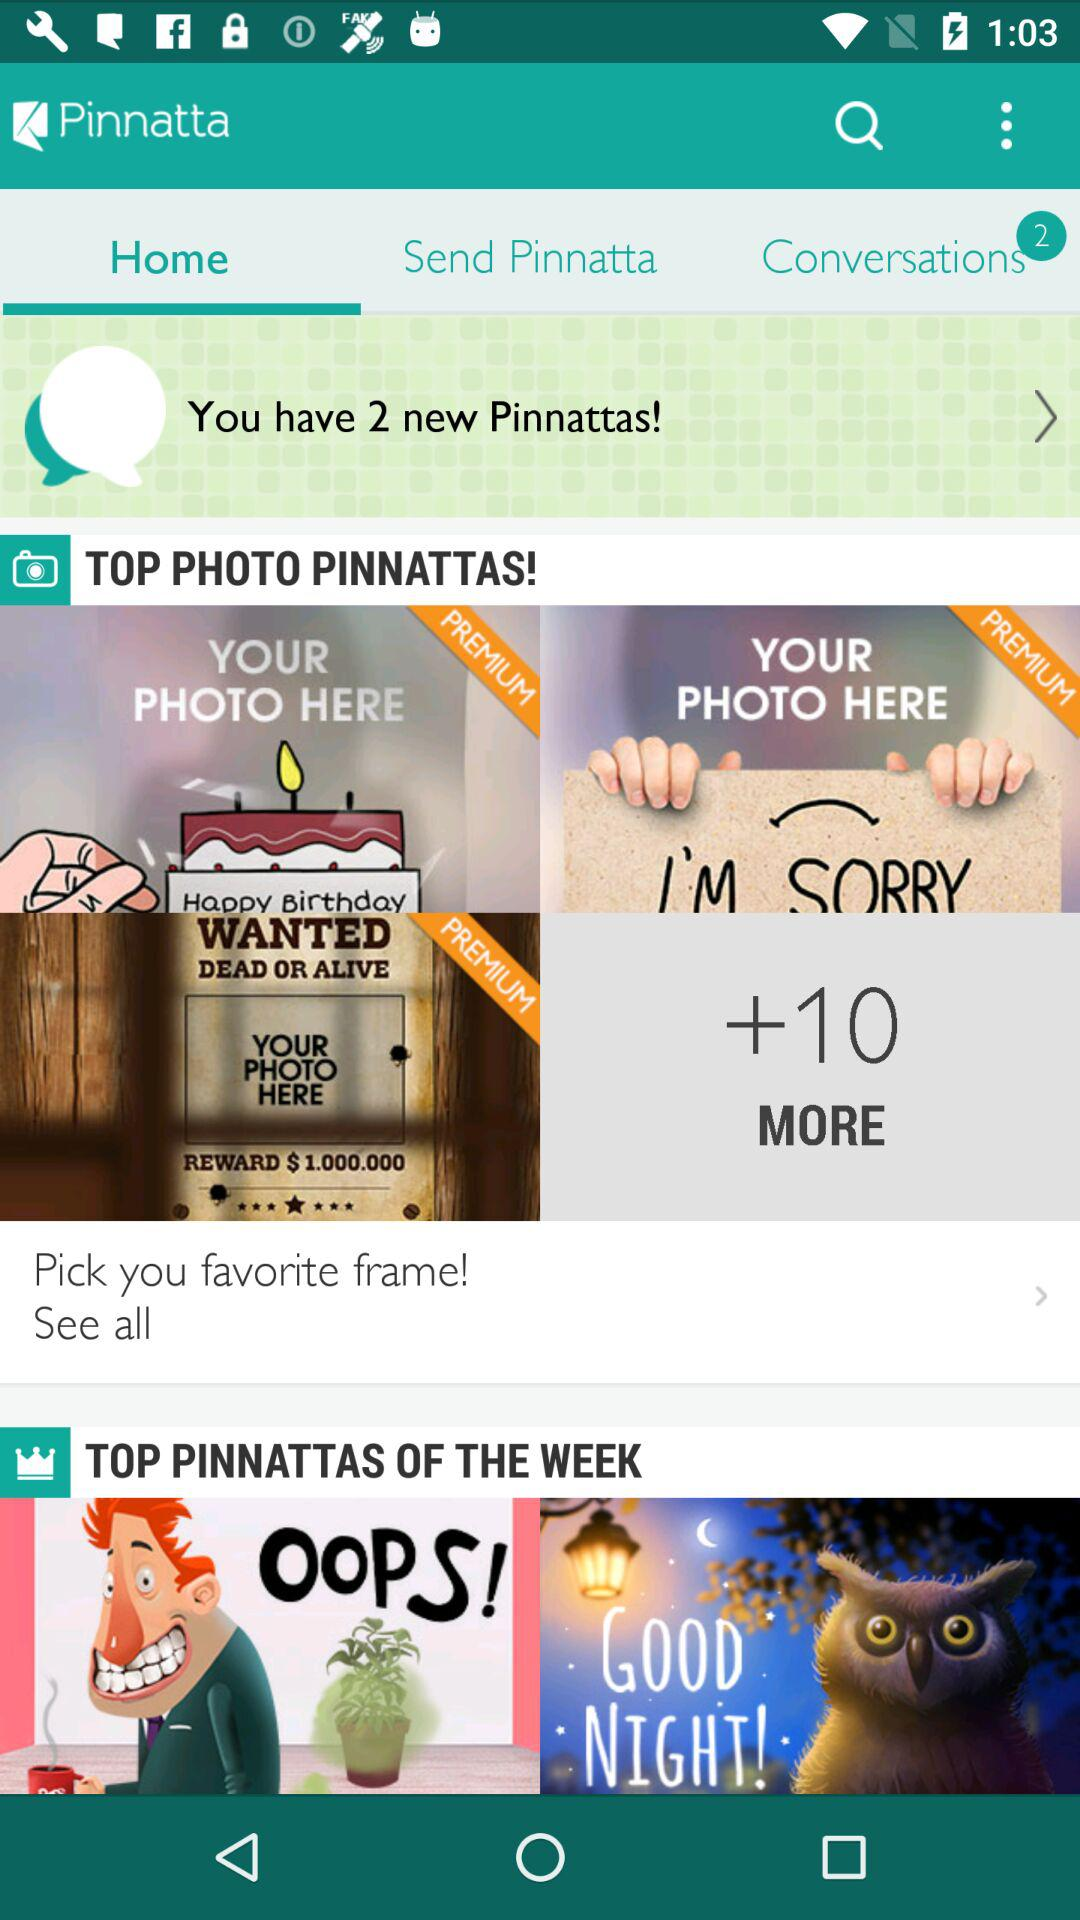How many premium pinnattas are there?
Answer the question using a single word or phrase. 2 